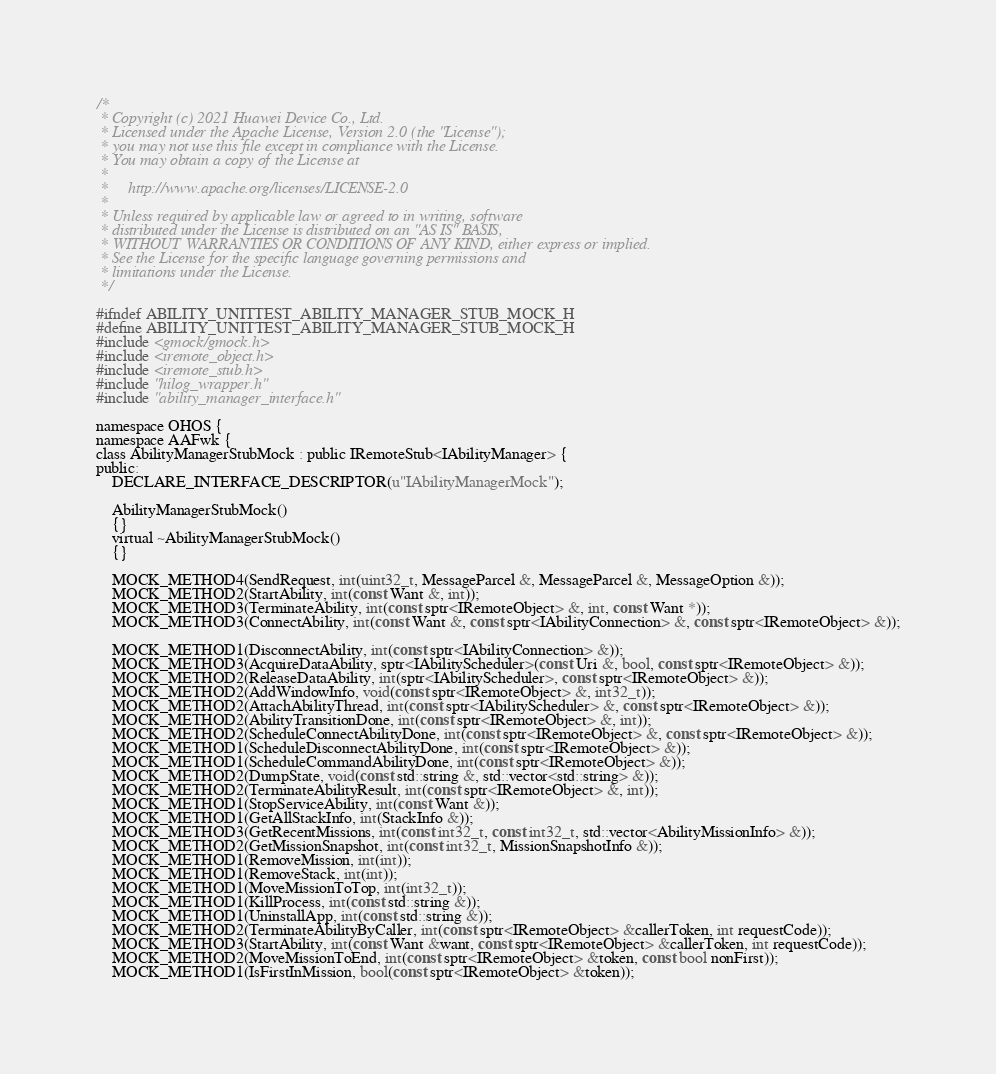<code> <loc_0><loc_0><loc_500><loc_500><_C_>/*
 * Copyright (c) 2021 Huawei Device Co., Ltd.
 * Licensed under the Apache License, Version 2.0 (the "License");
 * you may not use this file except in compliance with the License.
 * You may obtain a copy of the License at
 *
 *     http://www.apache.org/licenses/LICENSE-2.0
 *
 * Unless required by applicable law or agreed to in writing, software
 * distributed under the License is distributed on an "AS IS" BASIS,
 * WITHOUT WARRANTIES OR CONDITIONS OF ANY KIND, either express or implied.
 * See the License for the specific language governing permissions and
 * limitations under the License.
 */

#ifndef ABILITY_UNITTEST_ABILITY_MANAGER_STUB_MOCK_H
#define ABILITY_UNITTEST_ABILITY_MANAGER_STUB_MOCK_H
#include <gmock/gmock.h>
#include <iremote_object.h>
#include <iremote_stub.h>
#include "hilog_wrapper.h"
#include "ability_manager_interface.h"

namespace OHOS {
namespace AAFwk {
class AbilityManagerStubMock : public IRemoteStub<IAbilityManager> {
public:
    DECLARE_INTERFACE_DESCRIPTOR(u"IAbilityManagerMock");

    AbilityManagerStubMock()
    {}
    virtual ~AbilityManagerStubMock()
    {}

    MOCK_METHOD4(SendRequest, int(uint32_t, MessageParcel &, MessageParcel &, MessageOption &));
    MOCK_METHOD2(StartAbility, int(const Want &, int));
    MOCK_METHOD3(TerminateAbility, int(const sptr<IRemoteObject> &, int, const Want *));
    MOCK_METHOD3(ConnectAbility, int(const Want &, const sptr<IAbilityConnection> &, const sptr<IRemoteObject> &));

    MOCK_METHOD1(DisconnectAbility, int(const sptr<IAbilityConnection> &));
    MOCK_METHOD3(AcquireDataAbility, sptr<IAbilityScheduler>(const Uri &, bool, const sptr<IRemoteObject> &));
    MOCK_METHOD2(ReleaseDataAbility, int(sptr<IAbilityScheduler>, const sptr<IRemoteObject> &));
    MOCK_METHOD2(AddWindowInfo, void(const sptr<IRemoteObject> &, int32_t));
    MOCK_METHOD2(AttachAbilityThread, int(const sptr<IAbilityScheduler> &, const sptr<IRemoteObject> &));
    MOCK_METHOD2(AbilityTransitionDone, int(const sptr<IRemoteObject> &, int));
    MOCK_METHOD2(ScheduleConnectAbilityDone, int(const sptr<IRemoteObject> &, const sptr<IRemoteObject> &));
    MOCK_METHOD1(ScheduleDisconnectAbilityDone, int(const sptr<IRemoteObject> &));
    MOCK_METHOD1(ScheduleCommandAbilityDone, int(const sptr<IRemoteObject> &));
    MOCK_METHOD2(DumpState, void(const std::string &, std::vector<std::string> &));
    MOCK_METHOD2(TerminateAbilityResult, int(const sptr<IRemoteObject> &, int));
    MOCK_METHOD1(StopServiceAbility, int(const Want &));
    MOCK_METHOD1(GetAllStackInfo, int(StackInfo &));
    MOCK_METHOD3(GetRecentMissions, int(const int32_t, const int32_t, std::vector<AbilityMissionInfo> &));
    MOCK_METHOD2(GetMissionSnapshot, int(const int32_t, MissionSnapshotInfo &));
    MOCK_METHOD1(RemoveMission, int(int));
    MOCK_METHOD1(RemoveStack, int(int));
    MOCK_METHOD1(MoveMissionToTop, int(int32_t));
    MOCK_METHOD1(KillProcess, int(const std::string &));
    MOCK_METHOD1(UninstallApp, int(const std::string &));
    MOCK_METHOD2(TerminateAbilityByCaller, int(const sptr<IRemoteObject> &callerToken, int requestCode));
    MOCK_METHOD3(StartAbility, int(const Want &want, const sptr<IRemoteObject> &callerToken, int requestCode));
    MOCK_METHOD2(MoveMissionToEnd, int(const sptr<IRemoteObject> &token, const bool nonFirst));
    MOCK_METHOD1(IsFirstInMission, bool(const sptr<IRemoteObject> &token));</code> 